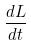Convert formula to latex. <formula><loc_0><loc_0><loc_500><loc_500>\frac { d L } { d t }</formula> 